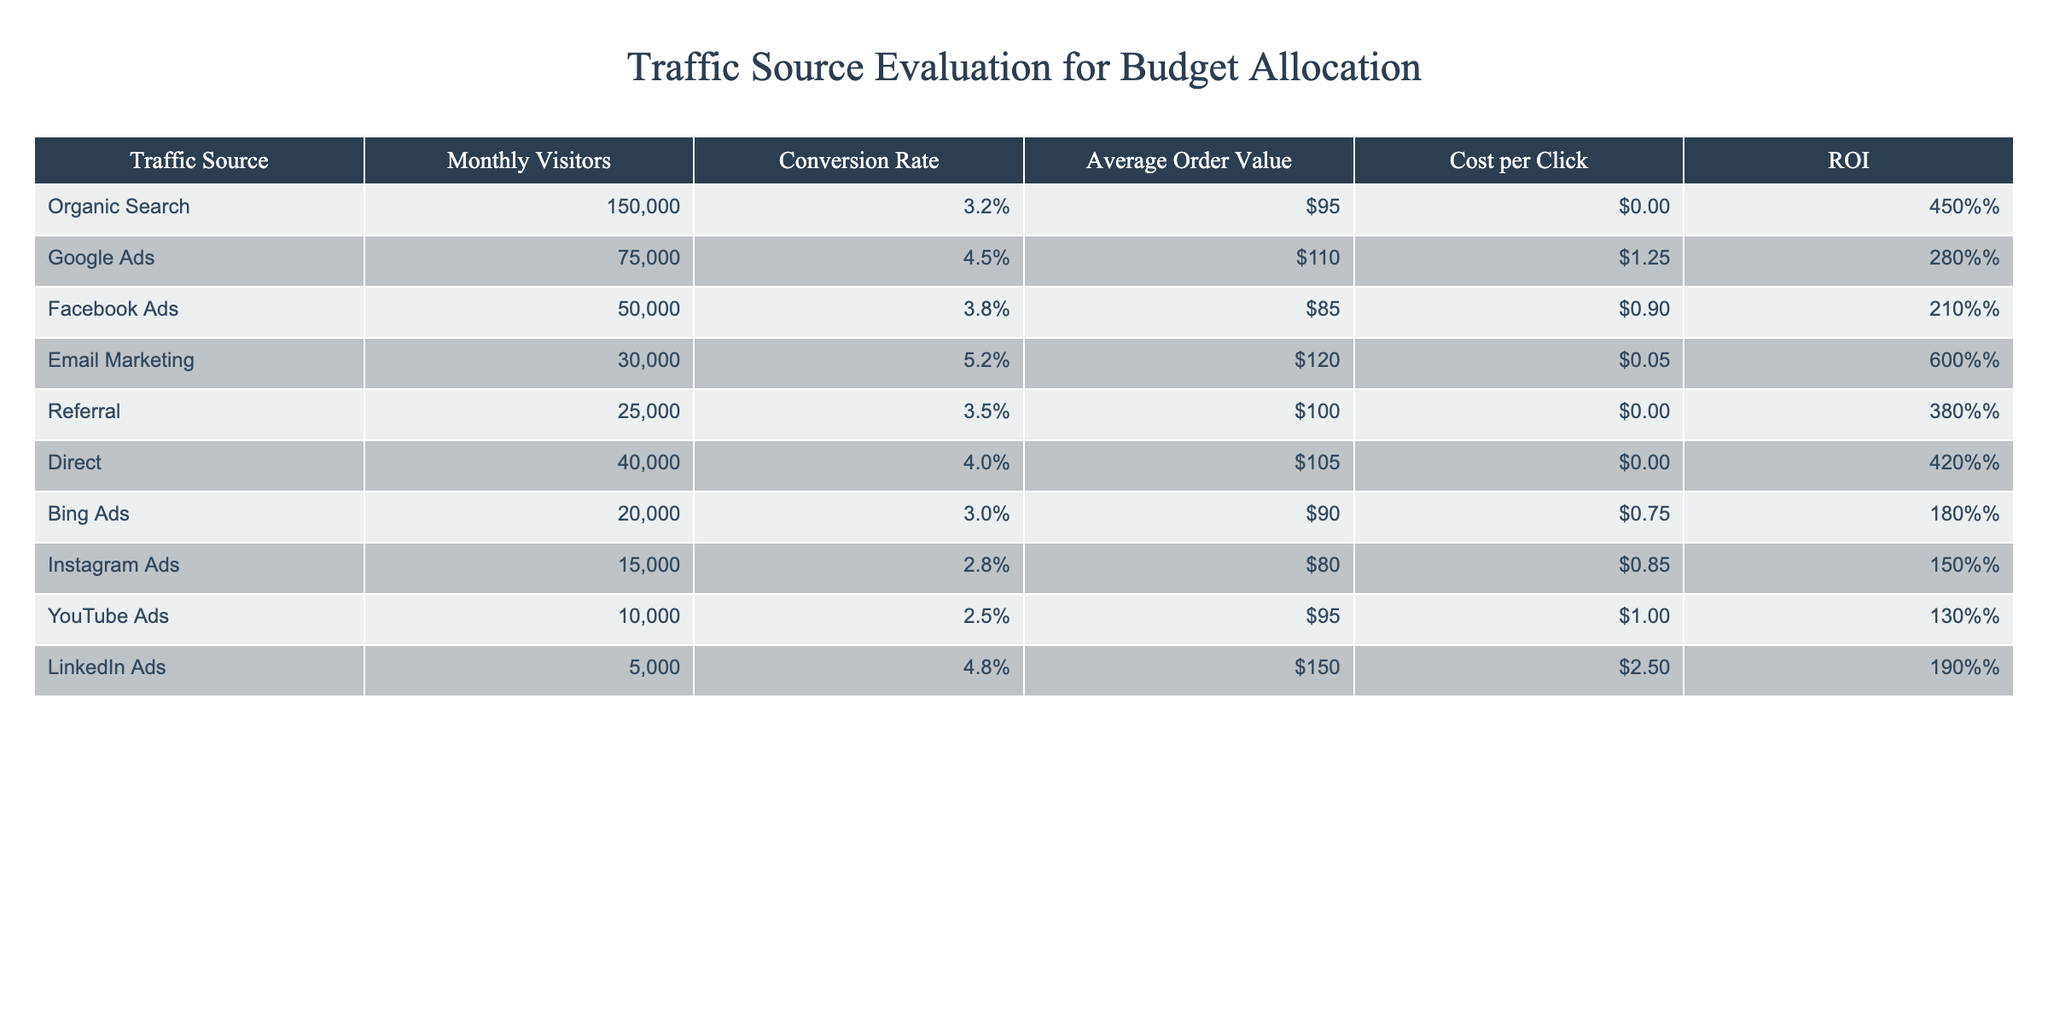What is the conversion rate for Email Marketing? The table lists Email Marketing with a conversion rate of 5.2%, which is taken directly from the "Conversion Rate" column.
Answer: 5.2% Which traffic source has the highest average order value? Reviewing the "Average Order Value" column, LinkedIn Ads has the highest average order value listed at $150.
Answer: LinkedIn Ads How many total monthly visitors do Social Media Ads bring in? The relevant traffic sources are Facebook Ads and Instagram Ads. Adding their monthly visitors together: 50,000 (Facebook Ads) + 15,000 (Instagram Ads) = 65,000.
Answer: 65,000 Is the ROI for Google Ads greater than 250%? The value for ROI for Google Ads is 280%, which is indeed greater than 250%.
Answer: Yes What is the difference in conversion rates between Email Marketing and Facebook Ads? The conversion rate for Email Marketing is 5.2% and for Facebook Ads is 3.8%. The difference is calculated as 5.2% - 3.8% = 1.4%.
Answer: 1.4% What percentage of monthly visitors come from Organic Search compared to Bing Ads? Organic Search has 150,000 monthly visitors and Bing Ads has 20,000. The percentage is calculated as (20,000 / 150,000) * 100 = 13.33%.
Answer: 13.33% Which traffic source has the lowest ROI? A comparison of the ROI values reveals that Instagram Ads have the lowest ROI at 150%. This is determined by checking the values in the "ROI" column.
Answer: Instagram Ads How much higher is the average order value of LinkedIn Ads compared to Facebook Ads? LinkedIn Ads have an average order value of $150, while Facebook Ads have $85. The difference is $150 - $85 = $65.
Answer: $65 Is the cost per click for YouTube Ads less than or equal to $1.00? Checking the "Cost per Click" for YouTube Ads shows it is $1.00, which means it is equal to $1.00.
Answer: Yes 